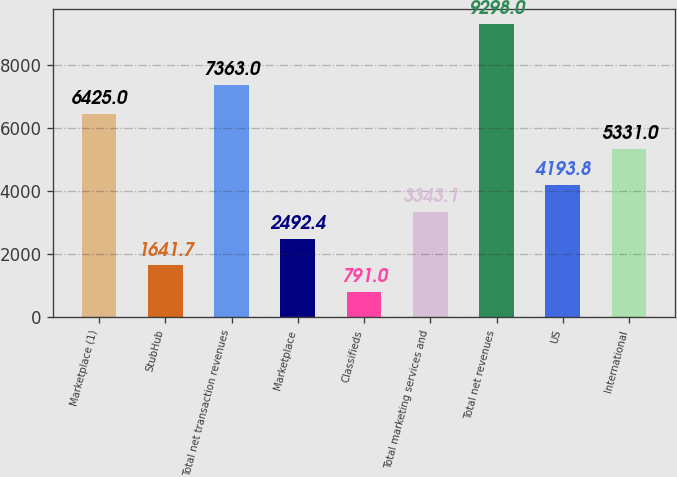Convert chart to OTSL. <chart><loc_0><loc_0><loc_500><loc_500><bar_chart><fcel>Marketplace (1)<fcel>StubHub<fcel>Total net transaction revenues<fcel>Marketplace<fcel>Classifieds<fcel>Total marketing services and<fcel>Total net revenues<fcel>US<fcel>International<nl><fcel>6425<fcel>1641.7<fcel>7363<fcel>2492.4<fcel>791<fcel>3343.1<fcel>9298<fcel>4193.8<fcel>5331<nl></chart> 